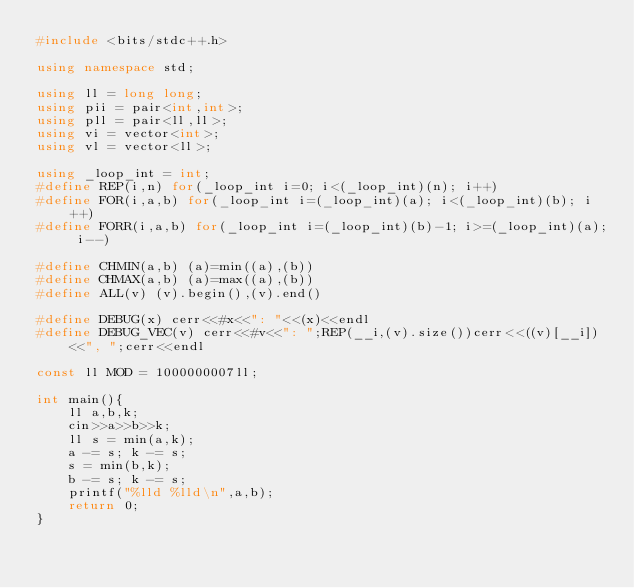Convert code to text. <code><loc_0><loc_0><loc_500><loc_500><_C++_>#include <bits/stdc++.h>

using namespace std;

using ll = long long;
using pii = pair<int,int>;
using pll = pair<ll,ll>;
using vi = vector<int>;
using vl = vector<ll>;

using _loop_int = int;
#define REP(i,n) for(_loop_int i=0; i<(_loop_int)(n); i++)
#define FOR(i,a,b) for(_loop_int i=(_loop_int)(a); i<(_loop_int)(b); i++)
#define FORR(i,a,b) for(_loop_int i=(_loop_int)(b)-1; i>=(_loop_int)(a); i--)

#define CHMIN(a,b) (a)=min((a),(b))
#define CHMAX(a,b) (a)=max((a),(b))
#define ALL(v) (v).begin(),(v).end()

#define DEBUG(x) cerr<<#x<<": "<<(x)<<endl
#define DEBUG_VEC(v) cerr<<#v<<": ";REP(__i,(v).size())cerr<<((v)[__i])<<", ";cerr<<endl

const ll MOD = 1000000007ll;

int main(){
    ll a,b,k;
    cin>>a>>b>>k;
    ll s = min(a,k);
    a -= s; k -= s;
    s = min(b,k);
    b -= s; k -= s;
    printf("%lld %lld\n",a,b);
    return 0;
}
</code> 